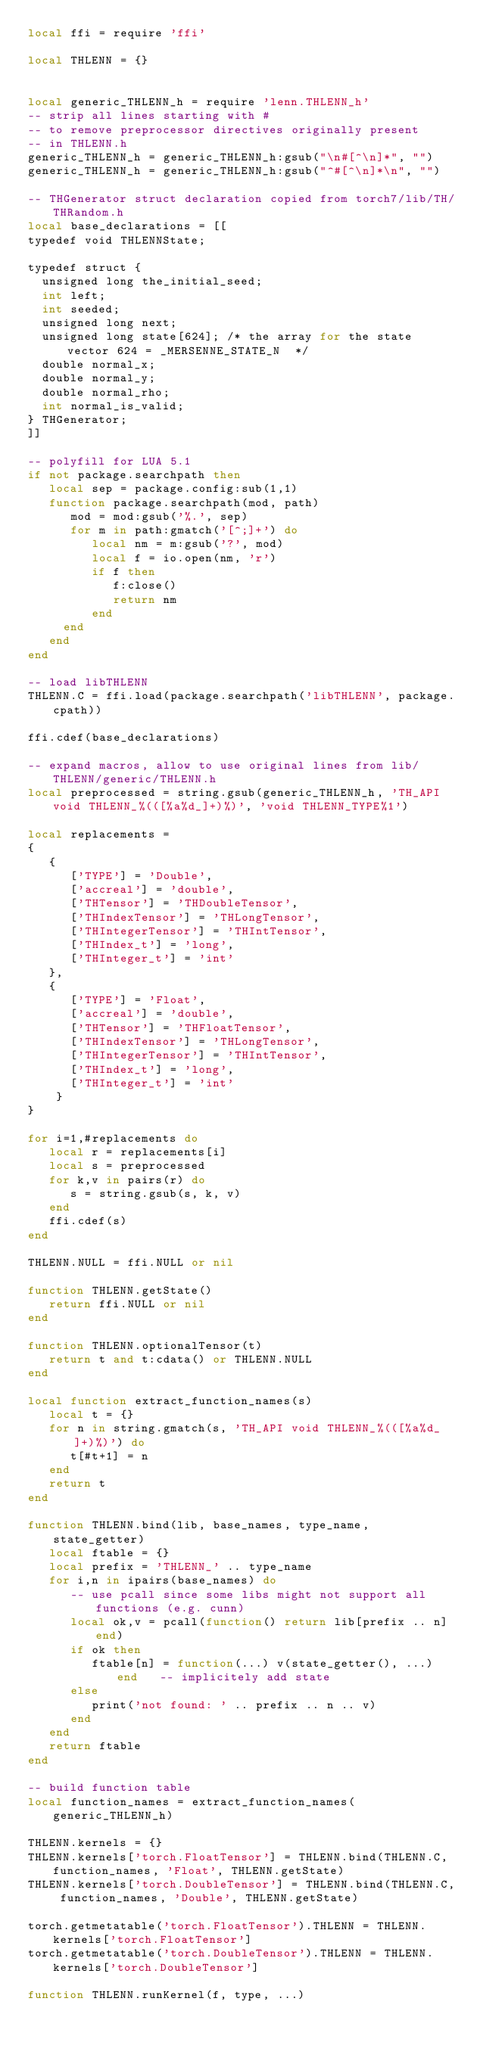<code> <loc_0><loc_0><loc_500><loc_500><_Lua_>local ffi = require 'ffi'

local THLENN = {}


local generic_THLENN_h = require 'lenn.THLENN_h'
-- strip all lines starting with #
-- to remove preprocessor directives originally present
-- in THLENN.h
generic_THLENN_h = generic_THLENN_h:gsub("\n#[^\n]*", "")
generic_THLENN_h = generic_THLENN_h:gsub("^#[^\n]*\n", "")

-- THGenerator struct declaration copied from torch7/lib/TH/THRandom.h
local base_declarations = [[
typedef void THLENNState;

typedef struct {
  unsigned long the_initial_seed;
  int left;
  int seeded;
  unsigned long next;
  unsigned long state[624]; /* the array for the state vector 624 = _MERSENNE_STATE_N  */
  double normal_x;
  double normal_y;
  double normal_rho;
  int normal_is_valid;
} THGenerator;
]]

-- polyfill for LUA 5.1
if not package.searchpath then
   local sep = package.config:sub(1,1)
   function package.searchpath(mod, path)
      mod = mod:gsub('%.', sep)
      for m in path:gmatch('[^;]+') do
         local nm = m:gsub('?', mod)
         local f = io.open(nm, 'r')
         if f then
            f:close()
            return nm
         end
     end
   end
end

-- load libTHLENN
THLENN.C = ffi.load(package.searchpath('libTHLENN', package.cpath))

ffi.cdef(base_declarations)

-- expand macros, allow to use original lines from lib/THLENN/generic/THLENN.h
local preprocessed = string.gsub(generic_THLENN_h, 'TH_API void THLENN_%(([%a%d_]+)%)', 'void THLENN_TYPE%1')

local replacements =
{
   {
      ['TYPE'] = 'Double',
      ['accreal'] = 'double',
      ['THTensor'] = 'THDoubleTensor',
      ['THIndexTensor'] = 'THLongTensor',
      ['THIntegerTensor'] = 'THIntTensor',
      ['THIndex_t'] = 'long',
      ['THInteger_t'] = 'int'
   },
   {
      ['TYPE'] = 'Float',
      ['accreal'] = 'double',
      ['THTensor'] = 'THFloatTensor',
      ['THIndexTensor'] = 'THLongTensor',
      ['THIntegerTensor'] = 'THIntTensor',
      ['THIndex_t'] = 'long',
      ['THInteger_t'] = 'int'
    }
}

for i=1,#replacements do
   local r = replacements[i]
   local s = preprocessed
   for k,v in pairs(r) do
      s = string.gsub(s, k, v)
   end
   ffi.cdef(s)
end

THLENN.NULL = ffi.NULL or nil

function THLENN.getState()
   return ffi.NULL or nil
end

function THLENN.optionalTensor(t)
   return t and t:cdata() or THLENN.NULL
end

local function extract_function_names(s)
   local t = {}
   for n in string.gmatch(s, 'TH_API void THLENN_%(([%a%d_]+)%)') do
      t[#t+1] = n
   end
   return t
end

function THLENN.bind(lib, base_names, type_name, state_getter)
   local ftable = {}
   local prefix = 'THLENN_' .. type_name
   for i,n in ipairs(base_names) do
      -- use pcall since some libs might not support all functions (e.g. cunn)
      local ok,v = pcall(function() return lib[prefix .. n] end)
      if ok then
         ftable[n] = function(...) v(state_getter(), ...) end   -- implicitely add state
      else
         print('not found: ' .. prefix .. n .. v)
      end
   end
   return ftable
end

-- build function table
local function_names = extract_function_names(generic_THLENN_h)

THLENN.kernels = {}
THLENN.kernels['torch.FloatTensor'] = THLENN.bind(THLENN.C, function_names, 'Float', THLENN.getState)
THLENN.kernels['torch.DoubleTensor'] = THLENN.bind(THLENN.C, function_names, 'Double', THLENN.getState)

torch.getmetatable('torch.FloatTensor').THLENN = THLENN.kernels['torch.FloatTensor']
torch.getmetatable('torch.DoubleTensor').THLENN = THLENN.kernels['torch.DoubleTensor']

function THLENN.runKernel(f, type, ...)</code> 